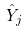<formula> <loc_0><loc_0><loc_500><loc_500>\hat { Y } _ { j }</formula> 